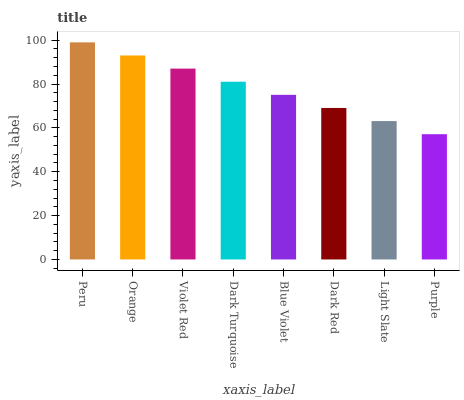Is Purple the minimum?
Answer yes or no. Yes. Is Peru the maximum?
Answer yes or no. Yes. Is Orange the minimum?
Answer yes or no. No. Is Orange the maximum?
Answer yes or no. No. Is Peru greater than Orange?
Answer yes or no. Yes. Is Orange less than Peru?
Answer yes or no. Yes. Is Orange greater than Peru?
Answer yes or no. No. Is Peru less than Orange?
Answer yes or no. No. Is Dark Turquoise the high median?
Answer yes or no. Yes. Is Blue Violet the low median?
Answer yes or no. Yes. Is Blue Violet the high median?
Answer yes or no. No. Is Dark Turquoise the low median?
Answer yes or no. No. 